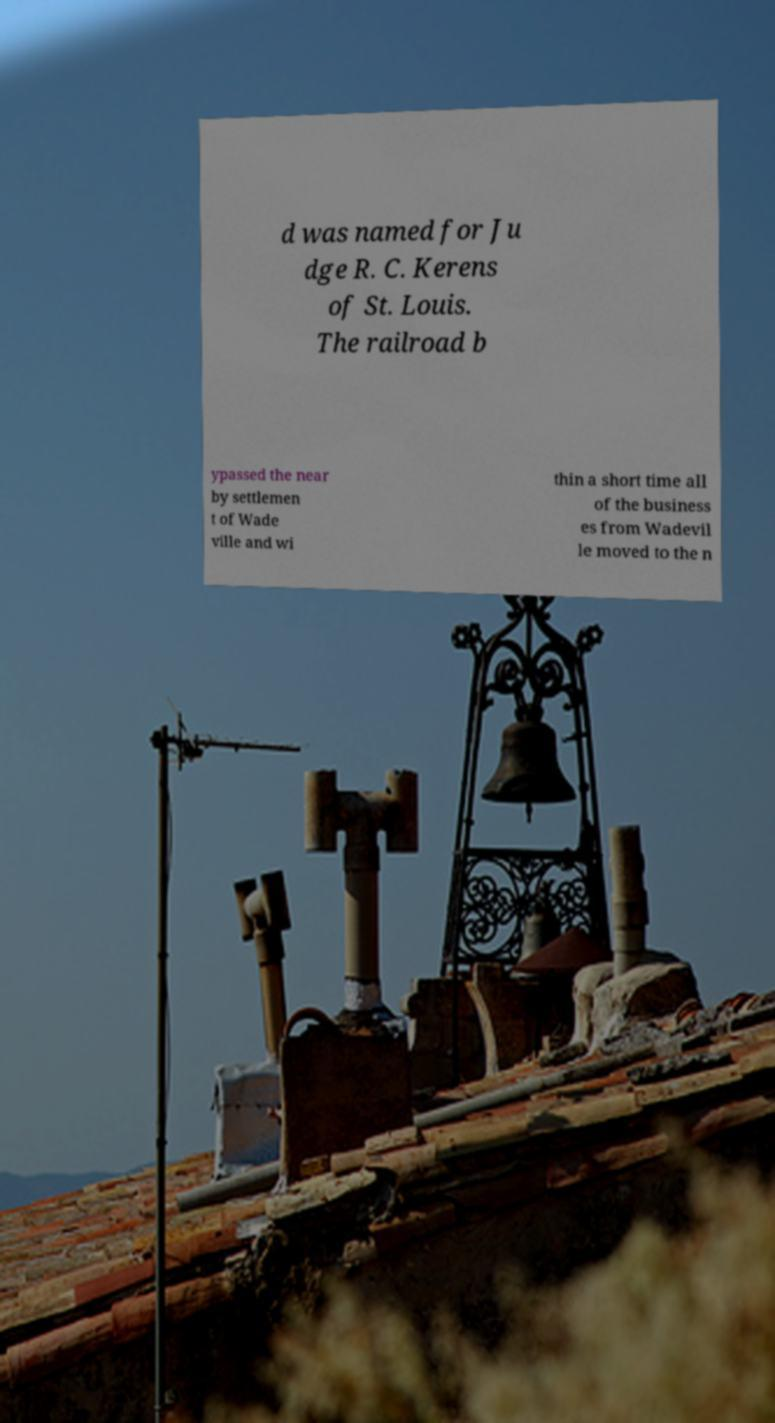For documentation purposes, I need the text within this image transcribed. Could you provide that? d was named for Ju dge R. C. Kerens of St. Louis. The railroad b ypassed the near by settlemen t of Wade ville and wi thin a short time all of the business es from Wadevil le moved to the n 